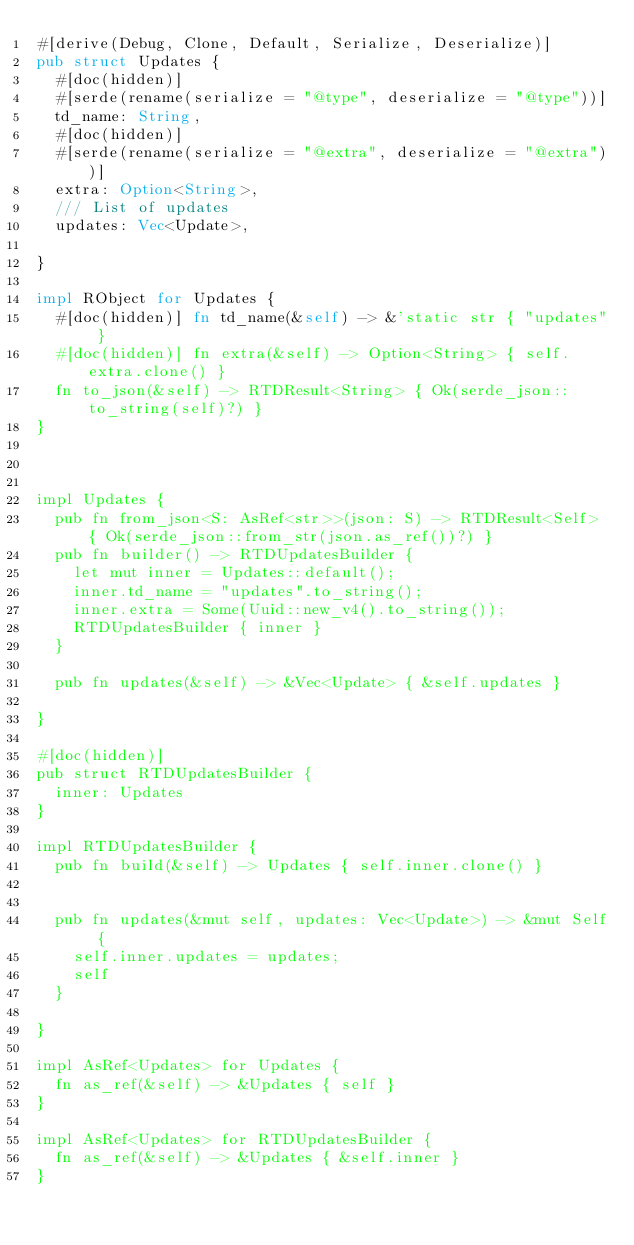<code> <loc_0><loc_0><loc_500><loc_500><_Rust_>#[derive(Debug, Clone, Default, Serialize, Deserialize)]
pub struct Updates {
  #[doc(hidden)]
  #[serde(rename(serialize = "@type", deserialize = "@type"))]
  td_name: String,
  #[doc(hidden)]
  #[serde(rename(serialize = "@extra", deserialize = "@extra"))]
  extra: Option<String>,
  /// List of updates
  updates: Vec<Update>,
  
}

impl RObject for Updates {
  #[doc(hidden)] fn td_name(&self) -> &'static str { "updates" }
  #[doc(hidden)] fn extra(&self) -> Option<String> { self.extra.clone() }
  fn to_json(&self) -> RTDResult<String> { Ok(serde_json::to_string(self)?) }
}



impl Updates {
  pub fn from_json<S: AsRef<str>>(json: S) -> RTDResult<Self> { Ok(serde_json::from_str(json.as_ref())?) }
  pub fn builder() -> RTDUpdatesBuilder {
    let mut inner = Updates::default();
    inner.td_name = "updates".to_string();
    inner.extra = Some(Uuid::new_v4().to_string());
    RTDUpdatesBuilder { inner }
  }

  pub fn updates(&self) -> &Vec<Update> { &self.updates }

}

#[doc(hidden)]
pub struct RTDUpdatesBuilder {
  inner: Updates
}

impl RTDUpdatesBuilder {
  pub fn build(&self) -> Updates { self.inner.clone() }

   
  pub fn updates(&mut self, updates: Vec<Update>) -> &mut Self {
    self.inner.updates = updates;
    self
  }

}

impl AsRef<Updates> for Updates {
  fn as_ref(&self) -> &Updates { self }
}

impl AsRef<Updates> for RTDUpdatesBuilder {
  fn as_ref(&self) -> &Updates { &self.inner }
}



</code> 